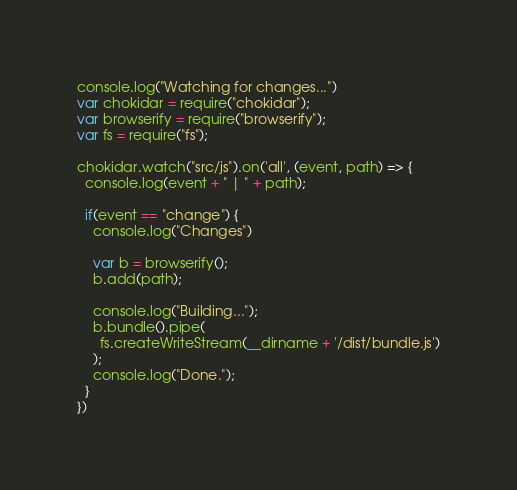<code> <loc_0><loc_0><loc_500><loc_500><_JavaScript_>console.log("Watching for changes...")
var chokidar = require("chokidar");
var browserify = require("browserify");
var fs = require("fs");

chokidar.watch("src/js").on('all', (event, path) => {
  console.log(event + " | " + path);
  
  if(event == "change") {
    console.log("Changes")
    
    var b = browserify();
    b.add(path);
    
    console.log("Building...");
    b.bundle().pipe(
      fs.createWriteStream(__dirname + '/dist/bundle.js')
    );
    console.log("Done.");
  }
})</code> 